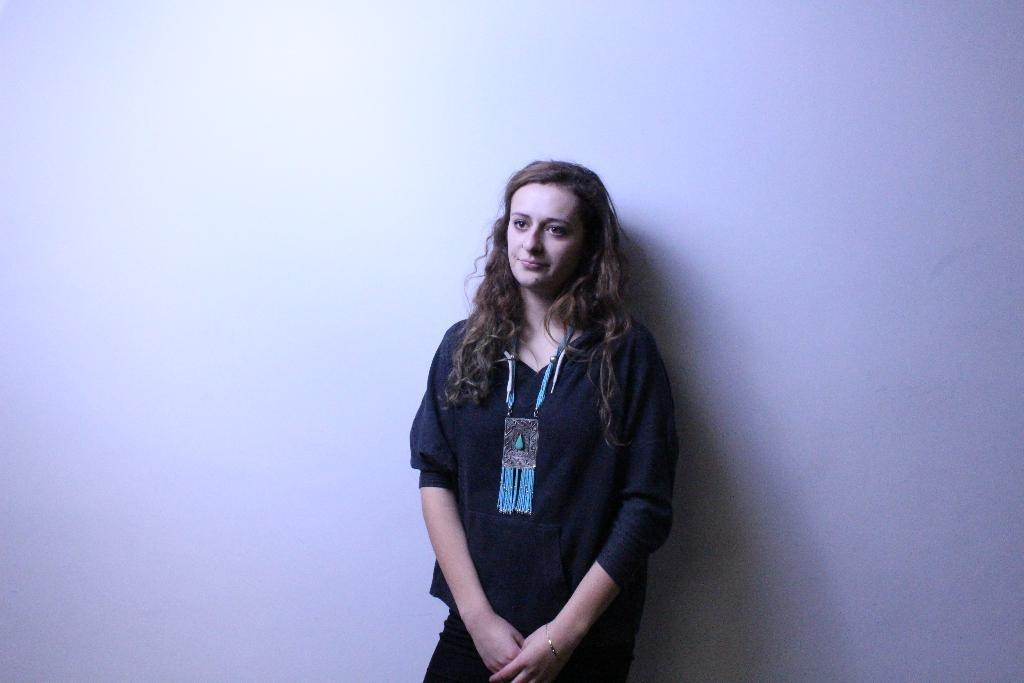Who is present in the image? There is a woman in the image. What is the woman wearing? The woman is wearing a black dress. What is the woman's facial expression? The woman is smiling. What can be seen in the background of the image? There is a white wall in the background of the image. What type of curtain is hanging in front of the woman in the image? There is no curtain present in the image; the woman is standing in front of a white wall. 